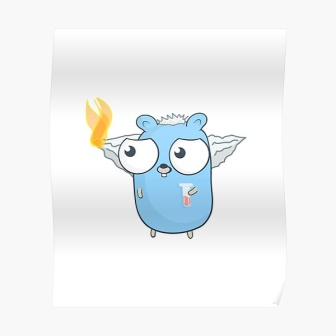Can you describe the main features of this image for me? The image showcases an imaginative and playful scene with a unique creature that bears a resemblance to a bear. The creature is distinctly painted in shades of blue and interestingly stands upright on two legs, similar to human posture. Adding an element of fantasy, it boasts wings that sprout from its back and a vivid flame burns atop its head, casting a gentle glow. Indicating a state of illness, the creature holds a thermometer in its mouth, suggesting it might have a fever. Despite this, it maintains a composed demeanor, with wide and alert eyes. The simplicity of the background, devoid of other objects or beings, ensures that all attention is drawn toward the creature, highlighting its quirky features. The creature's vibrant blue color stands out, making it the focal point of the image. The composition directs the viewer's gaze centrally towards this captivating and whimsical character, creating a visually compelling narrative. 